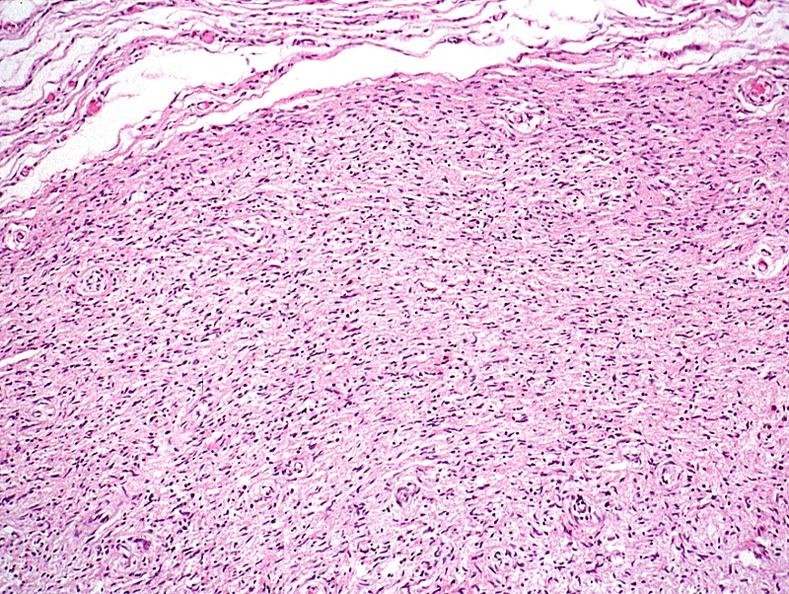what does this image show?
Answer the question using a single word or phrase. Skin 